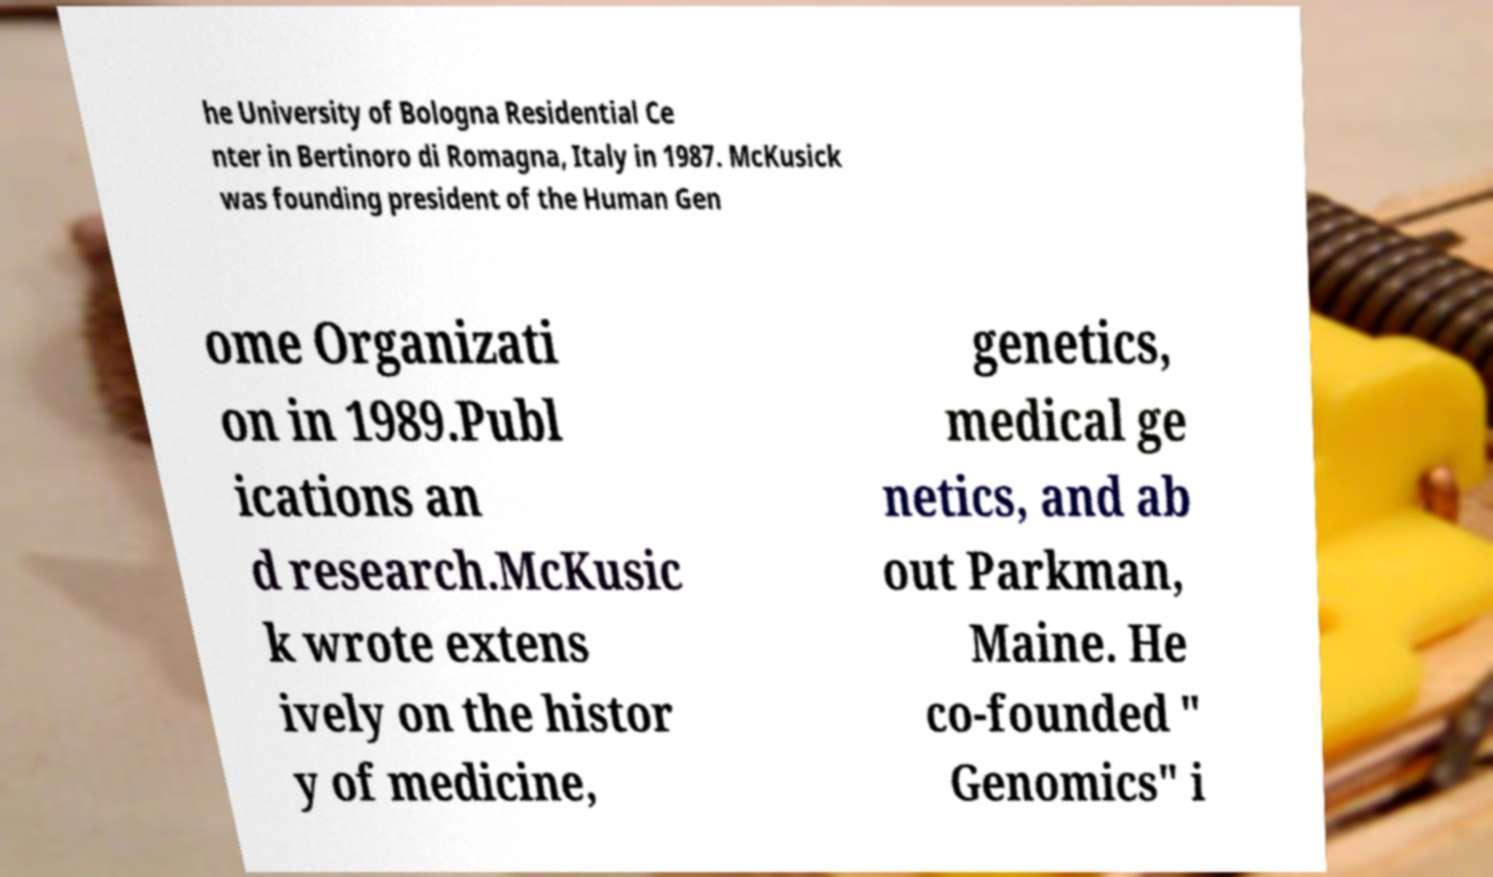I need the written content from this picture converted into text. Can you do that? he University of Bologna Residential Ce nter in Bertinoro di Romagna, Italy in 1987. McKusick was founding president of the Human Gen ome Organizati on in 1989.Publ ications an d research.McKusic k wrote extens ively on the histor y of medicine, genetics, medical ge netics, and ab out Parkman, Maine. He co-founded " Genomics" i 